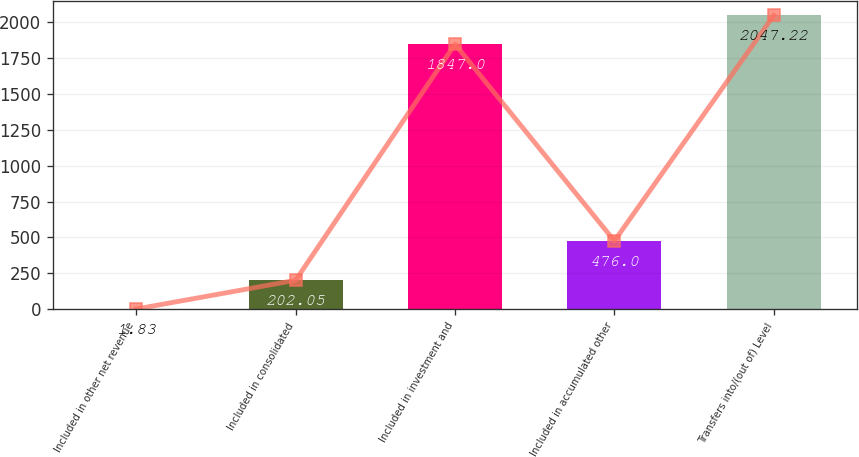<chart> <loc_0><loc_0><loc_500><loc_500><bar_chart><fcel>Included in other net revenue<fcel>Included in consolidated<fcel>Included in investment and<fcel>Included in accumulated other<fcel>Transfers into/(out of) Level<nl><fcel>1.83<fcel>202.05<fcel>1847<fcel>476<fcel>2047.22<nl></chart> 